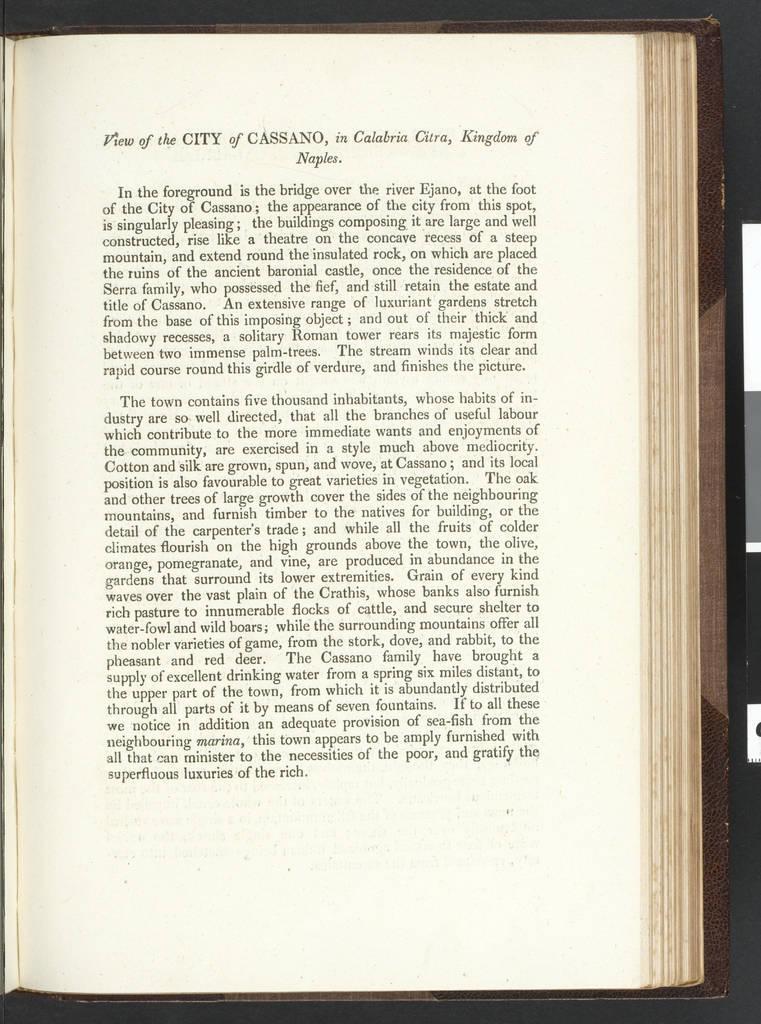Can you describe this image briefly? In this picture we can see a book with papers. On the paper, it is written something. 